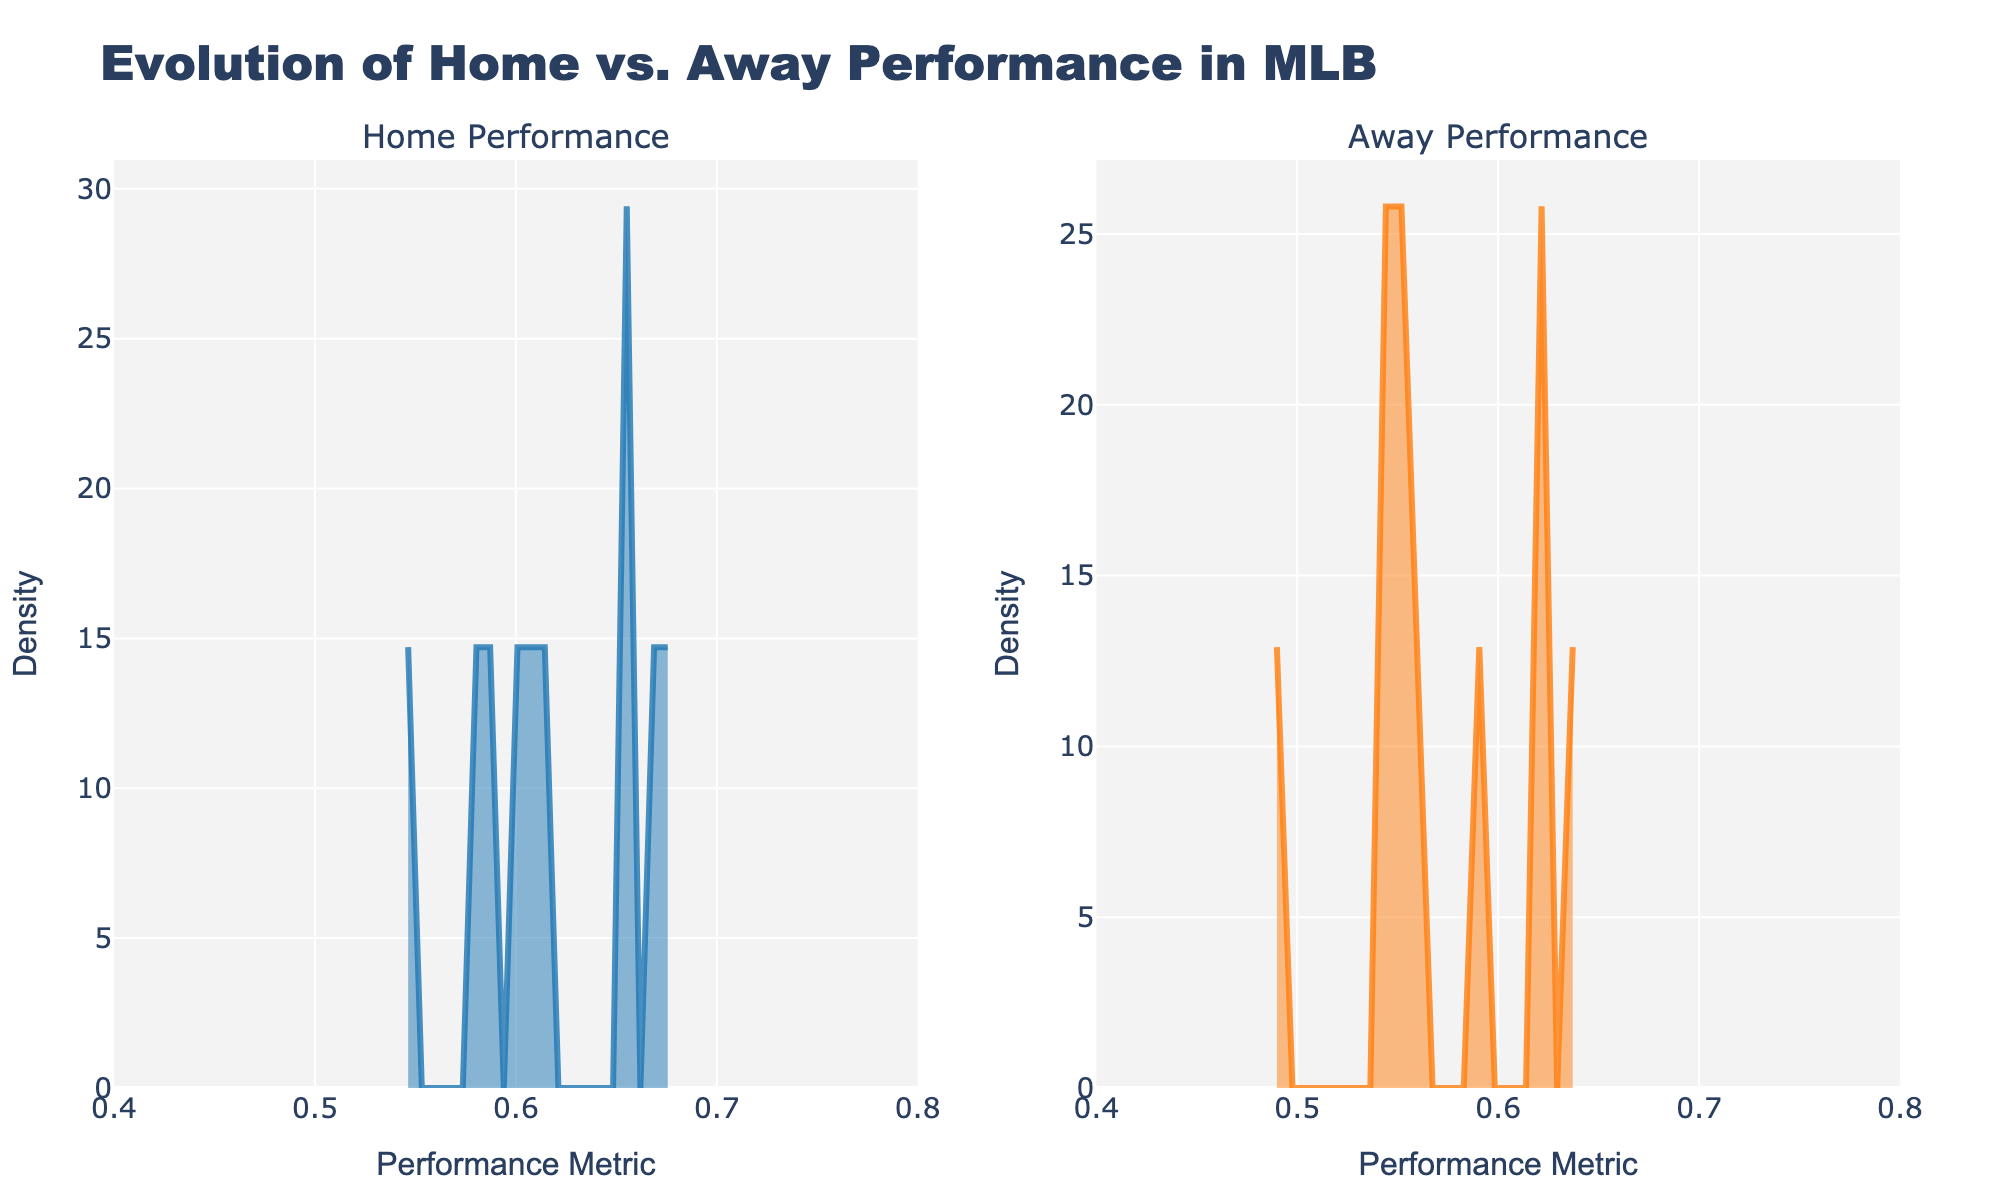What is the title of the figure? The title of the figure is displayed at the top. It reads "Evolution of Home vs. Away Performance in MLB".
Answer: Evolution of Home vs. Away Performance in MLB What are the x-axis labels of both subplots? Both subplots share the same x-axis label, which is "Performance Metric". You can see this text below each subplot along the horizontal axis.
Answer: Performance Metric What is the density range on the y-axis? Both subplots have their y-axes labeled "Density", and the values typically start from 0.
Answer: Density Which side, home or away, shows a higher peak density? By comparing the heights of the density peaks in both subplots, the home performance shows a higher peak density.
Answer: Home What is the range of performance metrics shown on both subplots? The x-axes of both subplots range from 0.4 to 0.8, as indicated by the tick marks and axis labels.
Answer: 0.4 to 0.8 What is the general color used for the home performance density plot? The density plot for home performance is predominantly shaded with a blue color.
Answer: Blue Which subplot shows a broader spread of performance metrics, home or away? By comparing the spread of the density plots, the away performance shows a slightly broader spread of performance metrics.
Answer: Away How do the overall densities for home and away performances compare in terms of shape and distribution? The home performance density plot is more peaked and has a sharper distribution, while the away performance density is slightly flatter indicating a broader distribution.
Answer: Home: sharper, Away: flatter Are there any visible trends in the density distributions that indicate differences between home and away performances? Yes, the home performance density has a more pronounced peak suggesting that teams generally perform better at home, while the away performance density is more spread out.
Answer: Teams perform better at home, away performance is more spread out How many subplots are in the figure? The figure consists of two subplots, one for home performance and one for away performance.
Answer: Two 